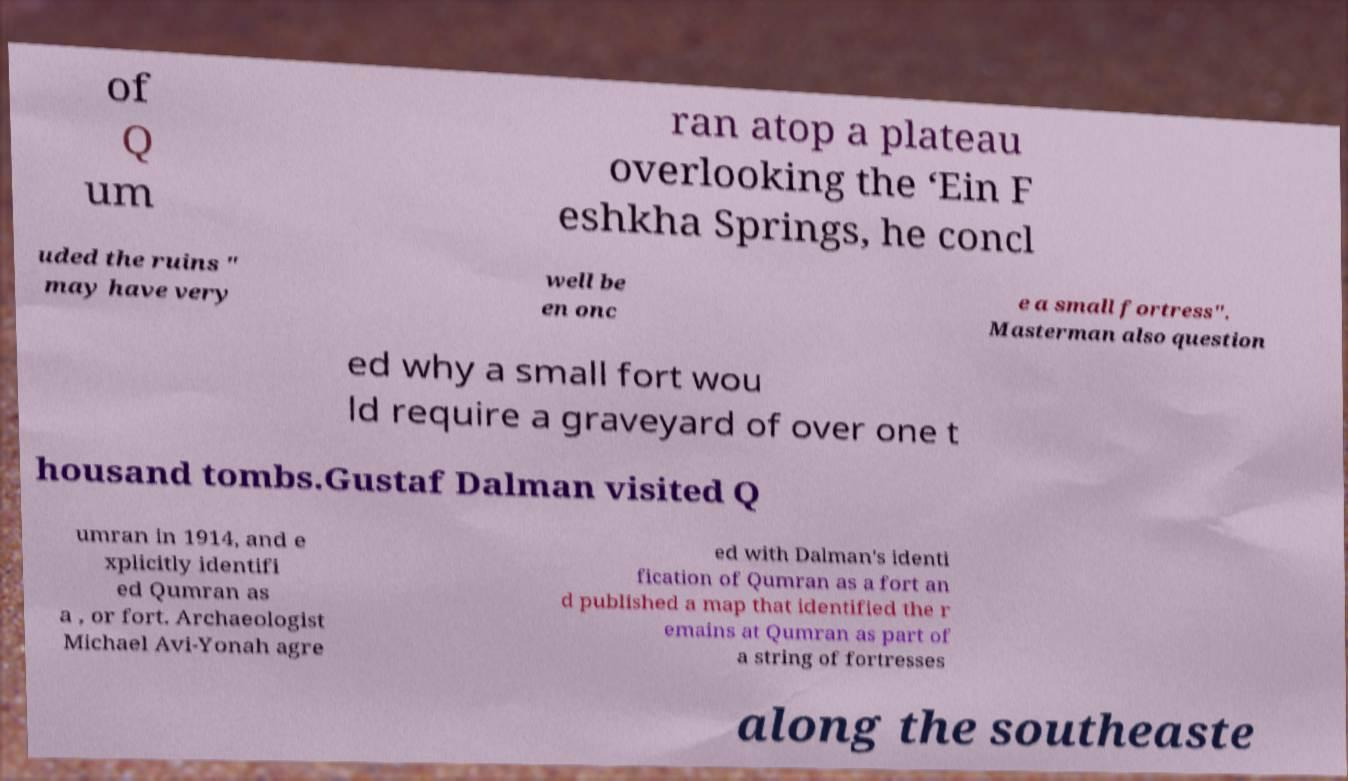Could you extract and type out the text from this image? of Q um ran atop a plateau overlooking the ‘Ein F eshkha Springs, he concl uded the ruins " may have very well be en onc e a small fortress". Masterman also question ed why a small fort wou ld require a graveyard of over one t housand tombs.Gustaf Dalman visited Q umran in 1914, and e xplicitly identifi ed Qumran as a , or fort. Archaeologist Michael Avi-Yonah agre ed with Dalman's identi fication of Qumran as a fort an d published a map that identified the r emains at Qumran as part of a string of fortresses along the southeaste 